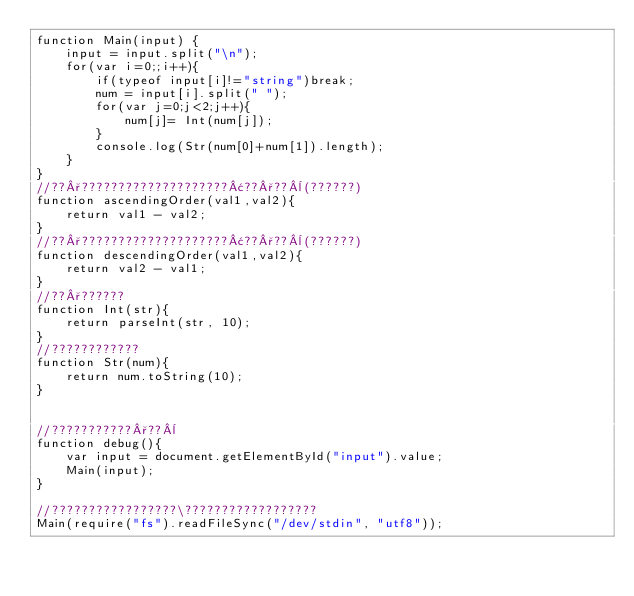<code> <loc_0><loc_0><loc_500><loc_500><_JavaScript_>function Main(input) {
    input = input.split("\n");
    for(var i=0;;i++){
        if(typeof input[i]!="string")break;
        num = input[i].split(" ");
        for(var j=0;j<2;j++){
            num[j]= Int(num[j]); 
        }
        console.log(Str(num[0]+num[1]).length);
    }
}
//??°????????????????????¢??°??¨(??????)
function ascendingOrder(val1,val2){
    return val1 - val2;
}
//??°????????????????????¢??°??¨(??????)
function descendingOrder(val1,val2){
    return val2 - val1;
}
//??°??????
function Int(str){
    return parseInt(str, 10);
}
//????????????
function Str(num){
    return num.toString(10);
}


//???????????°??¨
function debug(){
	var input = document.getElementById("input").value;
	Main(input);
}

//?????????????????\??????????????????
Main(require("fs").readFileSync("/dev/stdin", "utf8"));</code> 